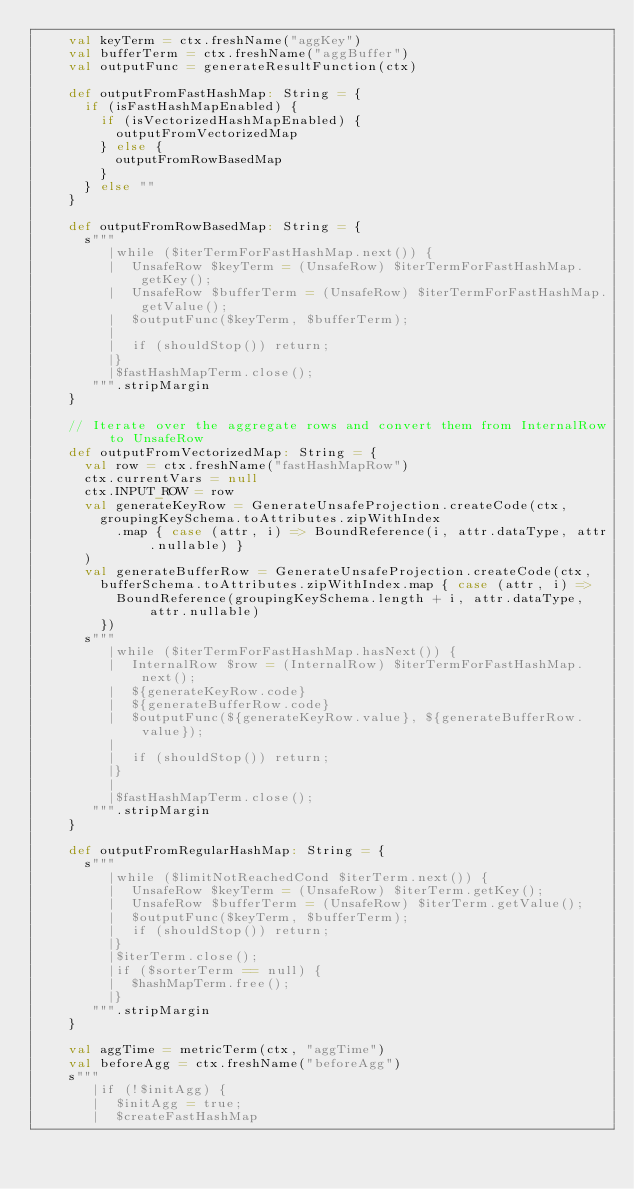Convert code to text. <code><loc_0><loc_0><loc_500><loc_500><_Scala_>    val keyTerm = ctx.freshName("aggKey")
    val bufferTerm = ctx.freshName("aggBuffer")
    val outputFunc = generateResultFunction(ctx)

    def outputFromFastHashMap: String = {
      if (isFastHashMapEnabled) {
        if (isVectorizedHashMapEnabled) {
          outputFromVectorizedMap
        } else {
          outputFromRowBasedMap
        }
      } else ""
    }

    def outputFromRowBasedMap: String = {
      s"""
         |while ($iterTermForFastHashMap.next()) {
         |  UnsafeRow $keyTerm = (UnsafeRow) $iterTermForFastHashMap.getKey();
         |  UnsafeRow $bufferTerm = (UnsafeRow) $iterTermForFastHashMap.getValue();
         |  $outputFunc($keyTerm, $bufferTerm);
         |
         |  if (shouldStop()) return;
         |}
         |$fastHashMapTerm.close();
       """.stripMargin
    }

    // Iterate over the aggregate rows and convert them from InternalRow to UnsafeRow
    def outputFromVectorizedMap: String = {
      val row = ctx.freshName("fastHashMapRow")
      ctx.currentVars = null
      ctx.INPUT_ROW = row
      val generateKeyRow = GenerateUnsafeProjection.createCode(ctx,
        groupingKeySchema.toAttributes.zipWithIndex
          .map { case (attr, i) => BoundReference(i, attr.dataType, attr.nullable) }
      )
      val generateBufferRow = GenerateUnsafeProjection.createCode(ctx,
        bufferSchema.toAttributes.zipWithIndex.map { case (attr, i) =>
          BoundReference(groupingKeySchema.length + i, attr.dataType, attr.nullable)
        })
      s"""
         |while ($iterTermForFastHashMap.hasNext()) {
         |  InternalRow $row = (InternalRow) $iterTermForFastHashMap.next();
         |  ${generateKeyRow.code}
         |  ${generateBufferRow.code}
         |  $outputFunc(${generateKeyRow.value}, ${generateBufferRow.value});
         |
         |  if (shouldStop()) return;
         |}
         |
         |$fastHashMapTerm.close();
       """.stripMargin
    }

    def outputFromRegularHashMap: String = {
      s"""
         |while ($limitNotReachedCond $iterTerm.next()) {
         |  UnsafeRow $keyTerm = (UnsafeRow) $iterTerm.getKey();
         |  UnsafeRow $bufferTerm = (UnsafeRow) $iterTerm.getValue();
         |  $outputFunc($keyTerm, $bufferTerm);
         |  if (shouldStop()) return;
         |}
         |$iterTerm.close();
         |if ($sorterTerm == null) {
         |  $hashMapTerm.free();
         |}
       """.stripMargin
    }

    val aggTime = metricTerm(ctx, "aggTime")
    val beforeAgg = ctx.freshName("beforeAgg")
    s"""
       |if (!$initAgg) {
       |  $initAgg = true;
       |  $createFastHashMap</code> 